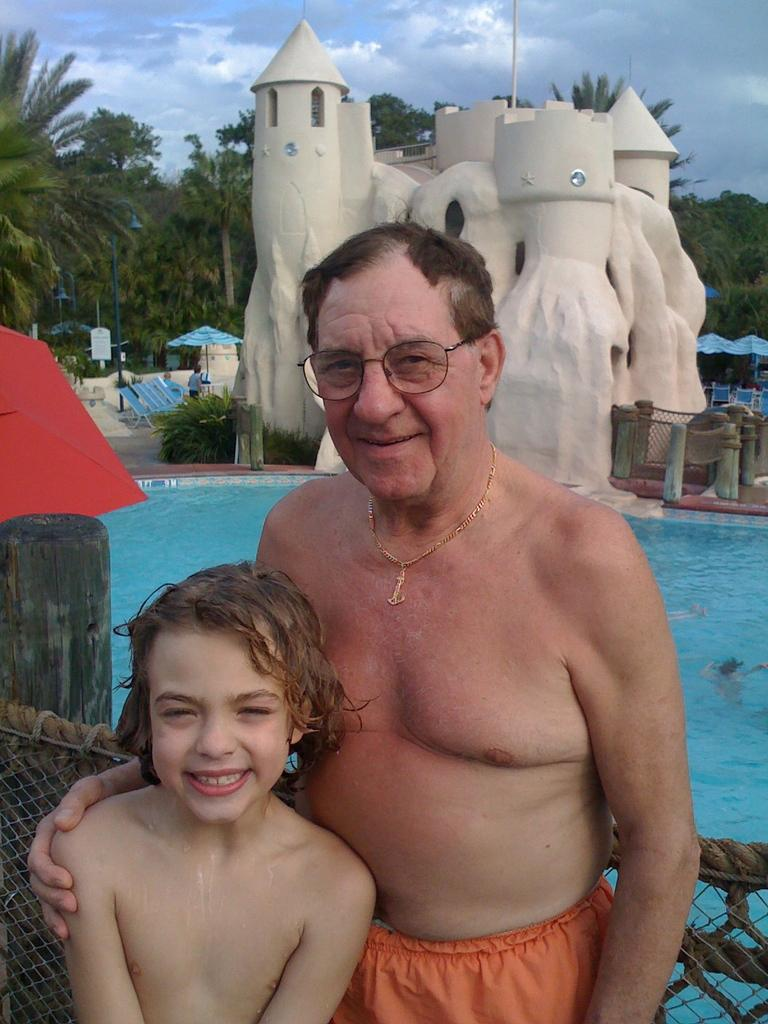Who is present in the image? There is a man and a kid in the image. Where are they standing? They are standing at the pool. What can be seen in the background of the image? There is a castle, water, a shack, trees, and the sky visible in the background. What word is being ordered by the man in the image? There is no indication in the image that the man is ordering any words, as the image does not contain any text or dialogue. 